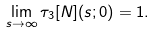<formula> <loc_0><loc_0><loc_500><loc_500>\lim _ { s \to \infty } \tau _ { 3 } [ N ] ( s ; 0 ) = 1 .</formula> 